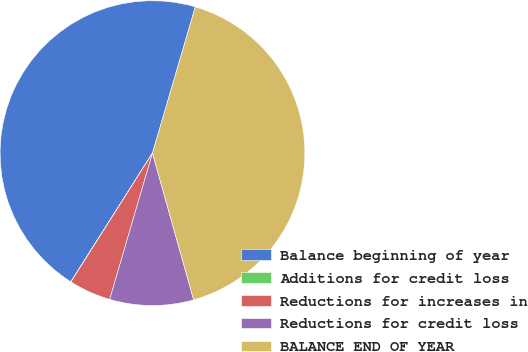Convert chart to OTSL. <chart><loc_0><loc_0><loc_500><loc_500><pie_chart><fcel>Balance beginning of year<fcel>Additions for credit loss<fcel>Reductions for increases in<fcel>Reductions for credit loss<fcel>BALANCE END OF YEAR<nl><fcel>45.53%<fcel>0.02%<fcel>4.45%<fcel>8.88%<fcel>41.1%<nl></chart> 